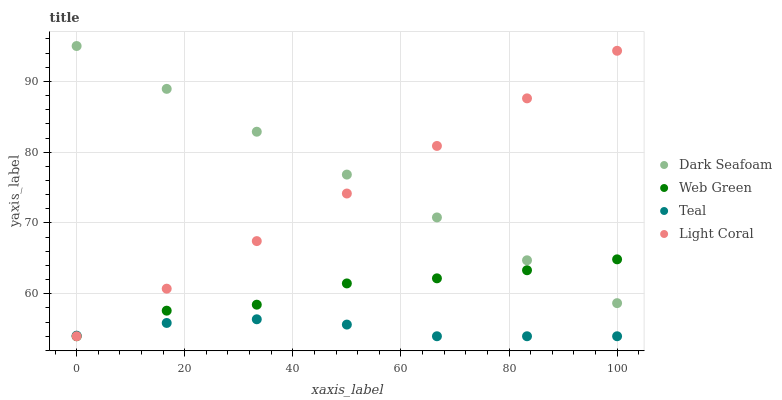Does Teal have the minimum area under the curve?
Answer yes or no. Yes. Does Dark Seafoam have the maximum area under the curve?
Answer yes or no. Yes. Does Dark Seafoam have the minimum area under the curve?
Answer yes or no. No. Does Teal have the maximum area under the curve?
Answer yes or no. No. Is Dark Seafoam the smoothest?
Answer yes or no. Yes. Is Web Green the roughest?
Answer yes or no. Yes. Is Teal the smoothest?
Answer yes or no. No. Is Teal the roughest?
Answer yes or no. No. Does Light Coral have the lowest value?
Answer yes or no. Yes. Does Dark Seafoam have the lowest value?
Answer yes or no. No. Does Dark Seafoam have the highest value?
Answer yes or no. Yes. Does Teal have the highest value?
Answer yes or no. No. Is Teal less than Dark Seafoam?
Answer yes or no. Yes. Is Dark Seafoam greater than Teal?
Answer yes or no. Yes. Does Dark Seafoam intersect Web Green?
Answer yes or no. Yes. Is Dark Seafoam less than Web Green?
Answer yes or no. No. Is Dark Seafoam greater than Web Green?
Answer yes or no. No. Does Teal intersect Dark Seafoam?
Answer yes or no. No. 